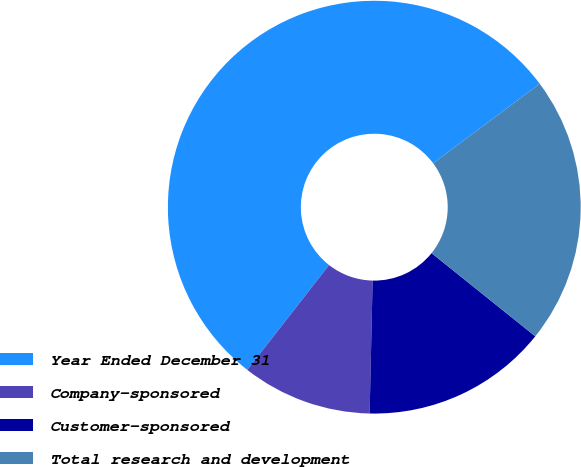Convert chart to OTSL. <chart><loc_0><loc_0><loc_500><loc_500><pie_chart><fcel>Year Ended December 31<fcel>Company-sponsored<fcel>Customer-sponsored<fcel>Total research and development<nl><fcel>54.25%<fcel>10.19%<fcel>14.6%<fcel>20.96%<nl></chart> 